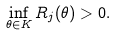<formula> <loc_0><loc_0><loc_500><loc_500>\inf _ { \theta \in K } R _ { j } ( \theta ) > 0 .</formula> 